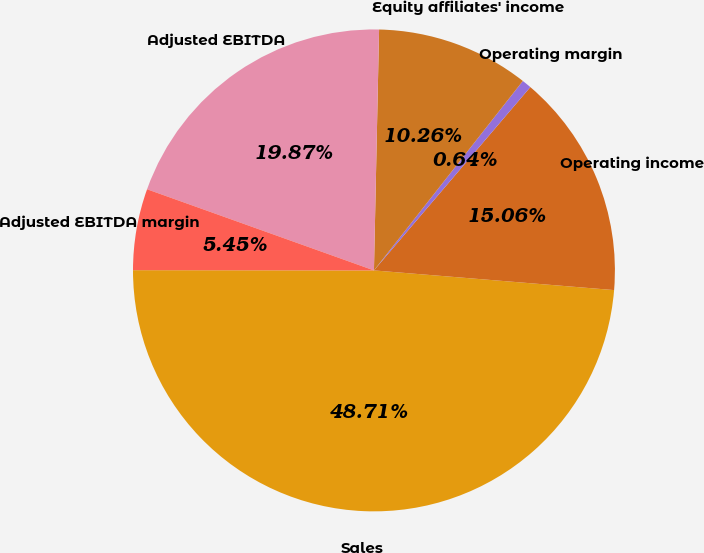<chart> <loc_0><loc_0><loc_500><loc_500><pie_chart><fcel>Sales<fcel>Operating income<fcel>Operating margin<fcel>Equity affiliates' income<fcel>Adjusted EBITDA<fcel>Adjusted EBITDA margin<nl><fcel>48.71%<fcel>15.06%<fcel>0.64%<fcel>10.26%<fcel>19.87%<fcel>5.45%<nl></chart> 